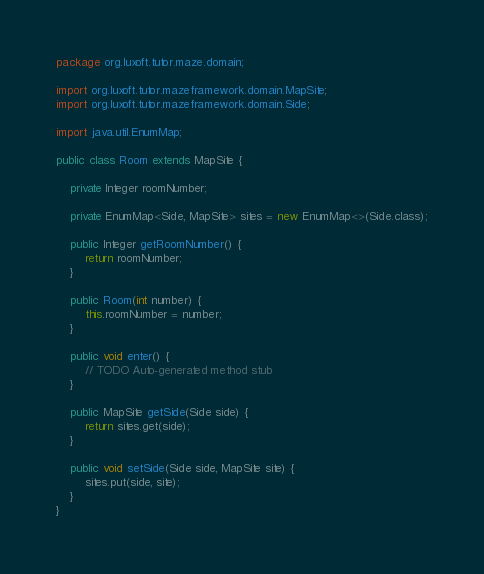Convert code to text. <code><loc_0><loc_0><loc_500><loc_500><_Java_>package org.luxoft.tutor.maze.domain;

import org.luxoft.tutor.mazeframework.domain.MapSite;
import org.luxoft.tutor.mazeframework.domain.Side;

import java.util.EnumMap;

public class Room extends MapSite {

	private Integer roomNumber;

	private EnumMap<Side, MapSite> sites = new EnumMap<>(Side.class);

	public Integer getRoomNumber() {
		return roomNumber;
	}

	public Room(int number) {
		this.roomNumber = number;
	}

	public void enter() {
		// TODO Auto-generated method stub
	}

	public MapSite getSide(Side side) {
		return sites.get(side);
	}

	public void setSide(Side side, MapSite site) {
		sites.put(side, site);
	}
}
</code> 